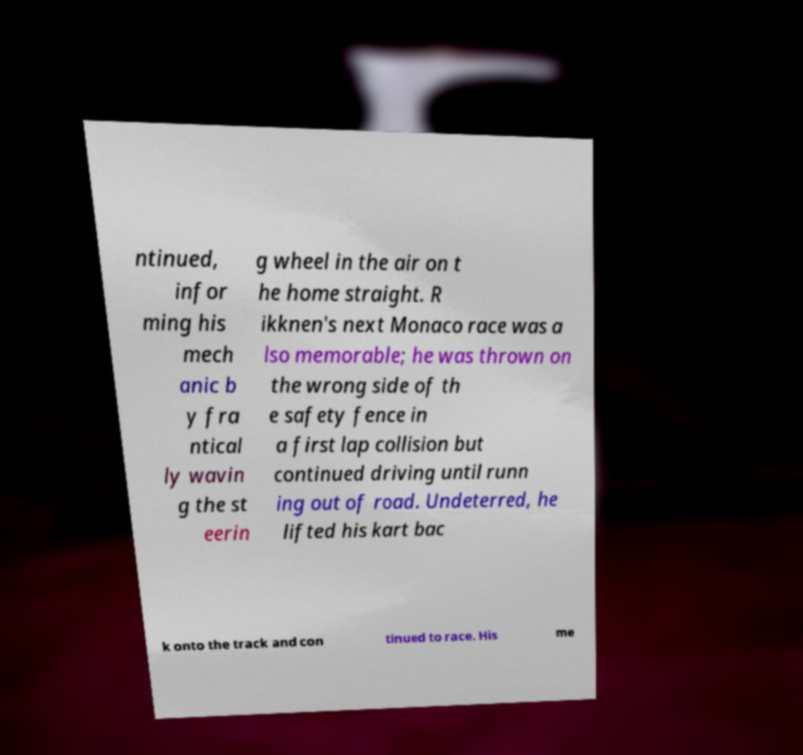Could you assist in decoding the text presented in this image and type it out clearly? ntinued, infor ming his mech anic b y fra ntical ly wavin g the st eerin g wheel in the air on t he home straight. R ikknen's next Monaco race was a lso memorable; he was thrown on the wrong side of th e safety fence in a first lap collision but continued driving until runn ing out of road. Undeterred, he lifted his kart bac k onto the track and con tinued to race. His me 